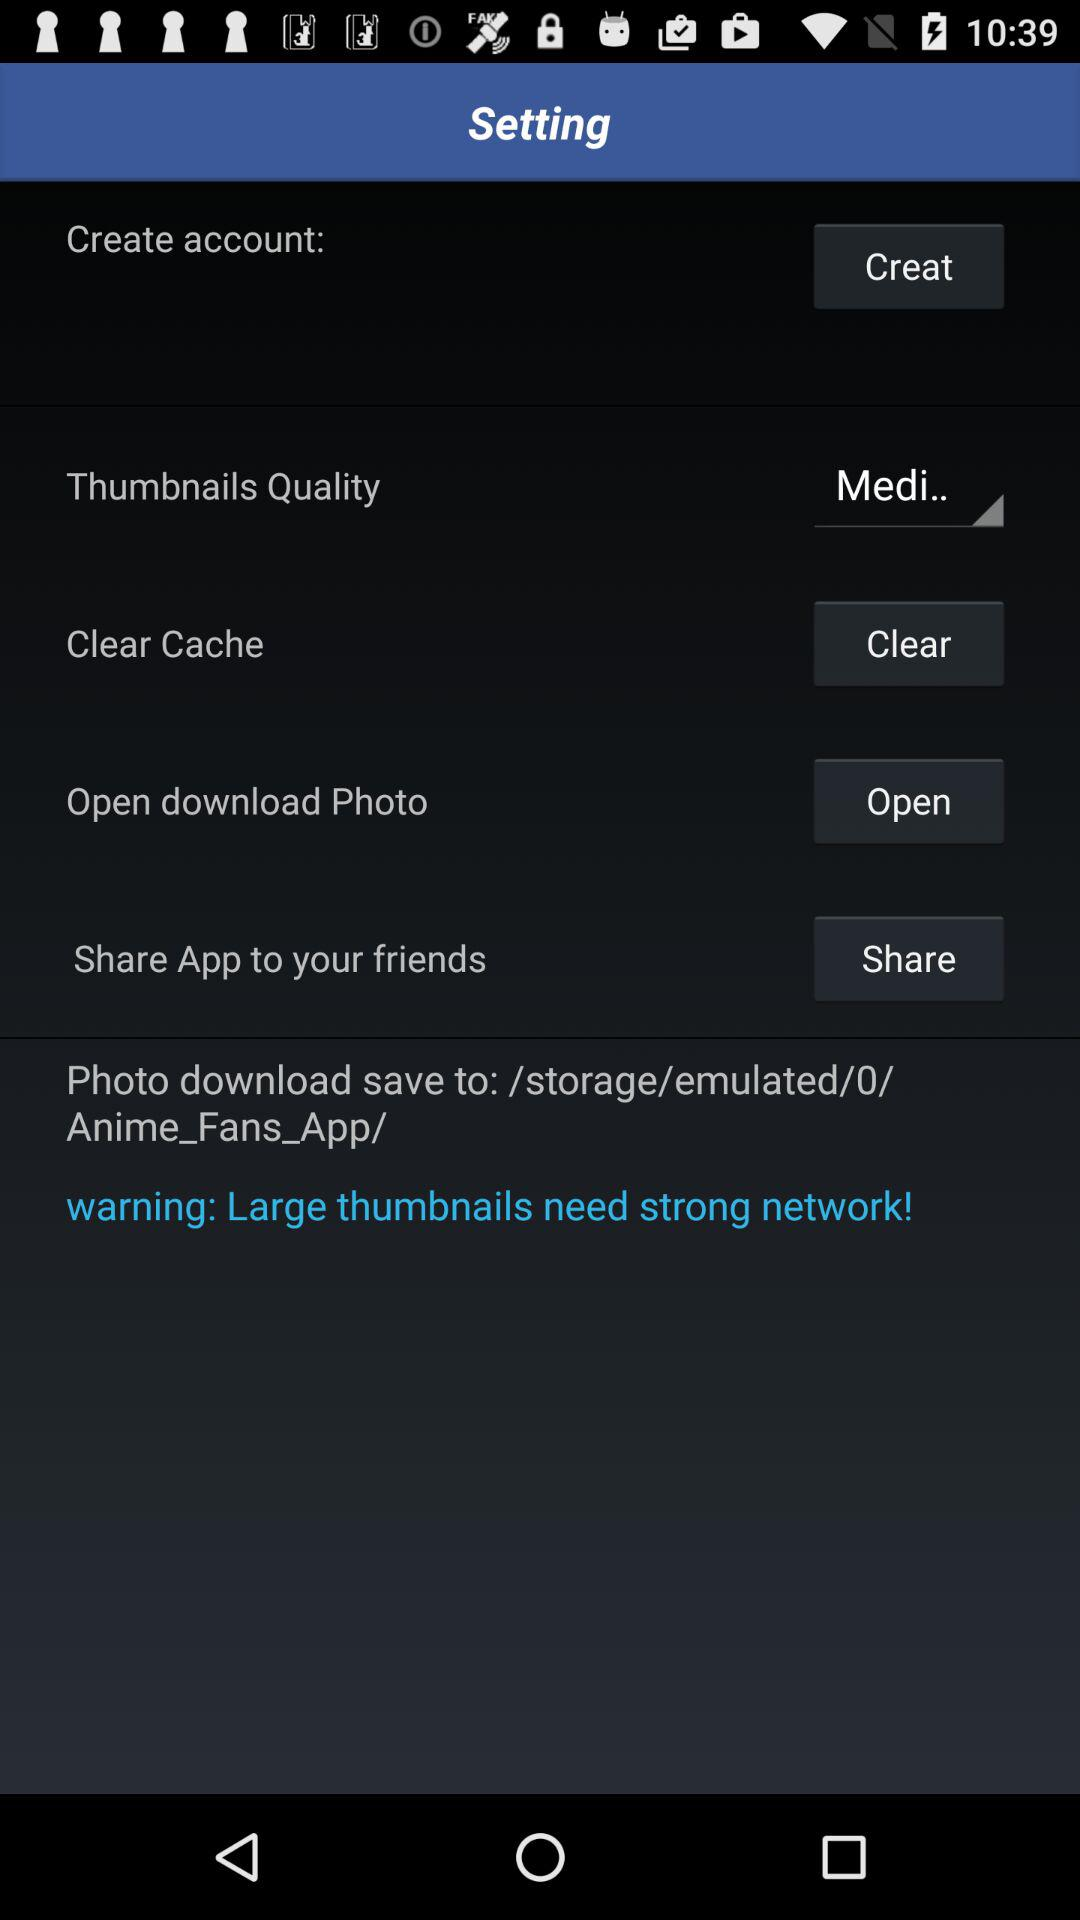What is the requirement for large thumbnails? The requirement for large thumbnails is a strong network. 